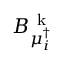<formula> <loc_0><loc_0><loc_500><loc_500>B _ { \mu _ { i } ^ { \dagger } } ^ { k }</formula> 